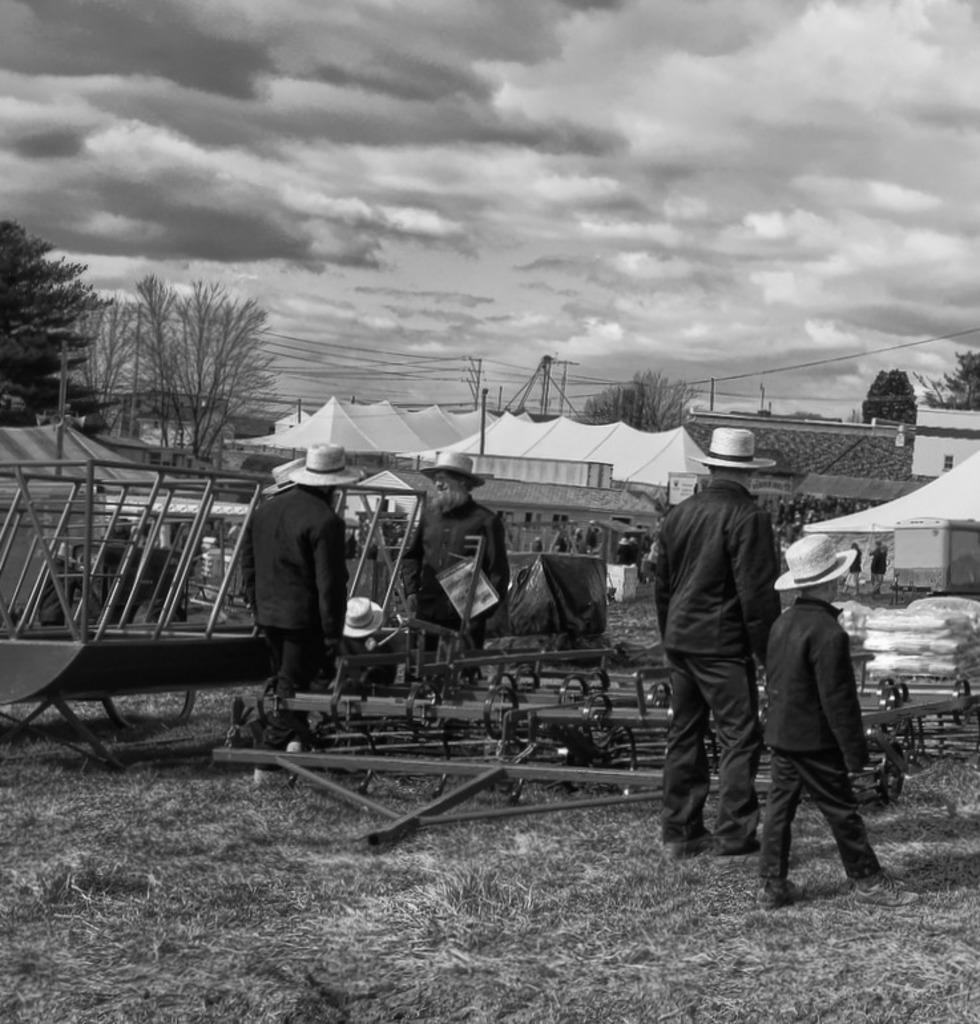What can be seen in the image? There are people standing in the image, along with white color tents and trees. What is the color of the tents in the image? The tents in the image are white. What is visible at the top of the image? The sky is visible at the top of the image. What is the condition of the sky in the image? The sky is cloudy in the image. What flavor of cake is being served at the hour depicted in the image? There is no cake present in the image, and no specific hour is depicted. How many breaths can be counted coming from the trees in the image? Trees do not breathe, so it is not possible to count breaths from them in the image. 